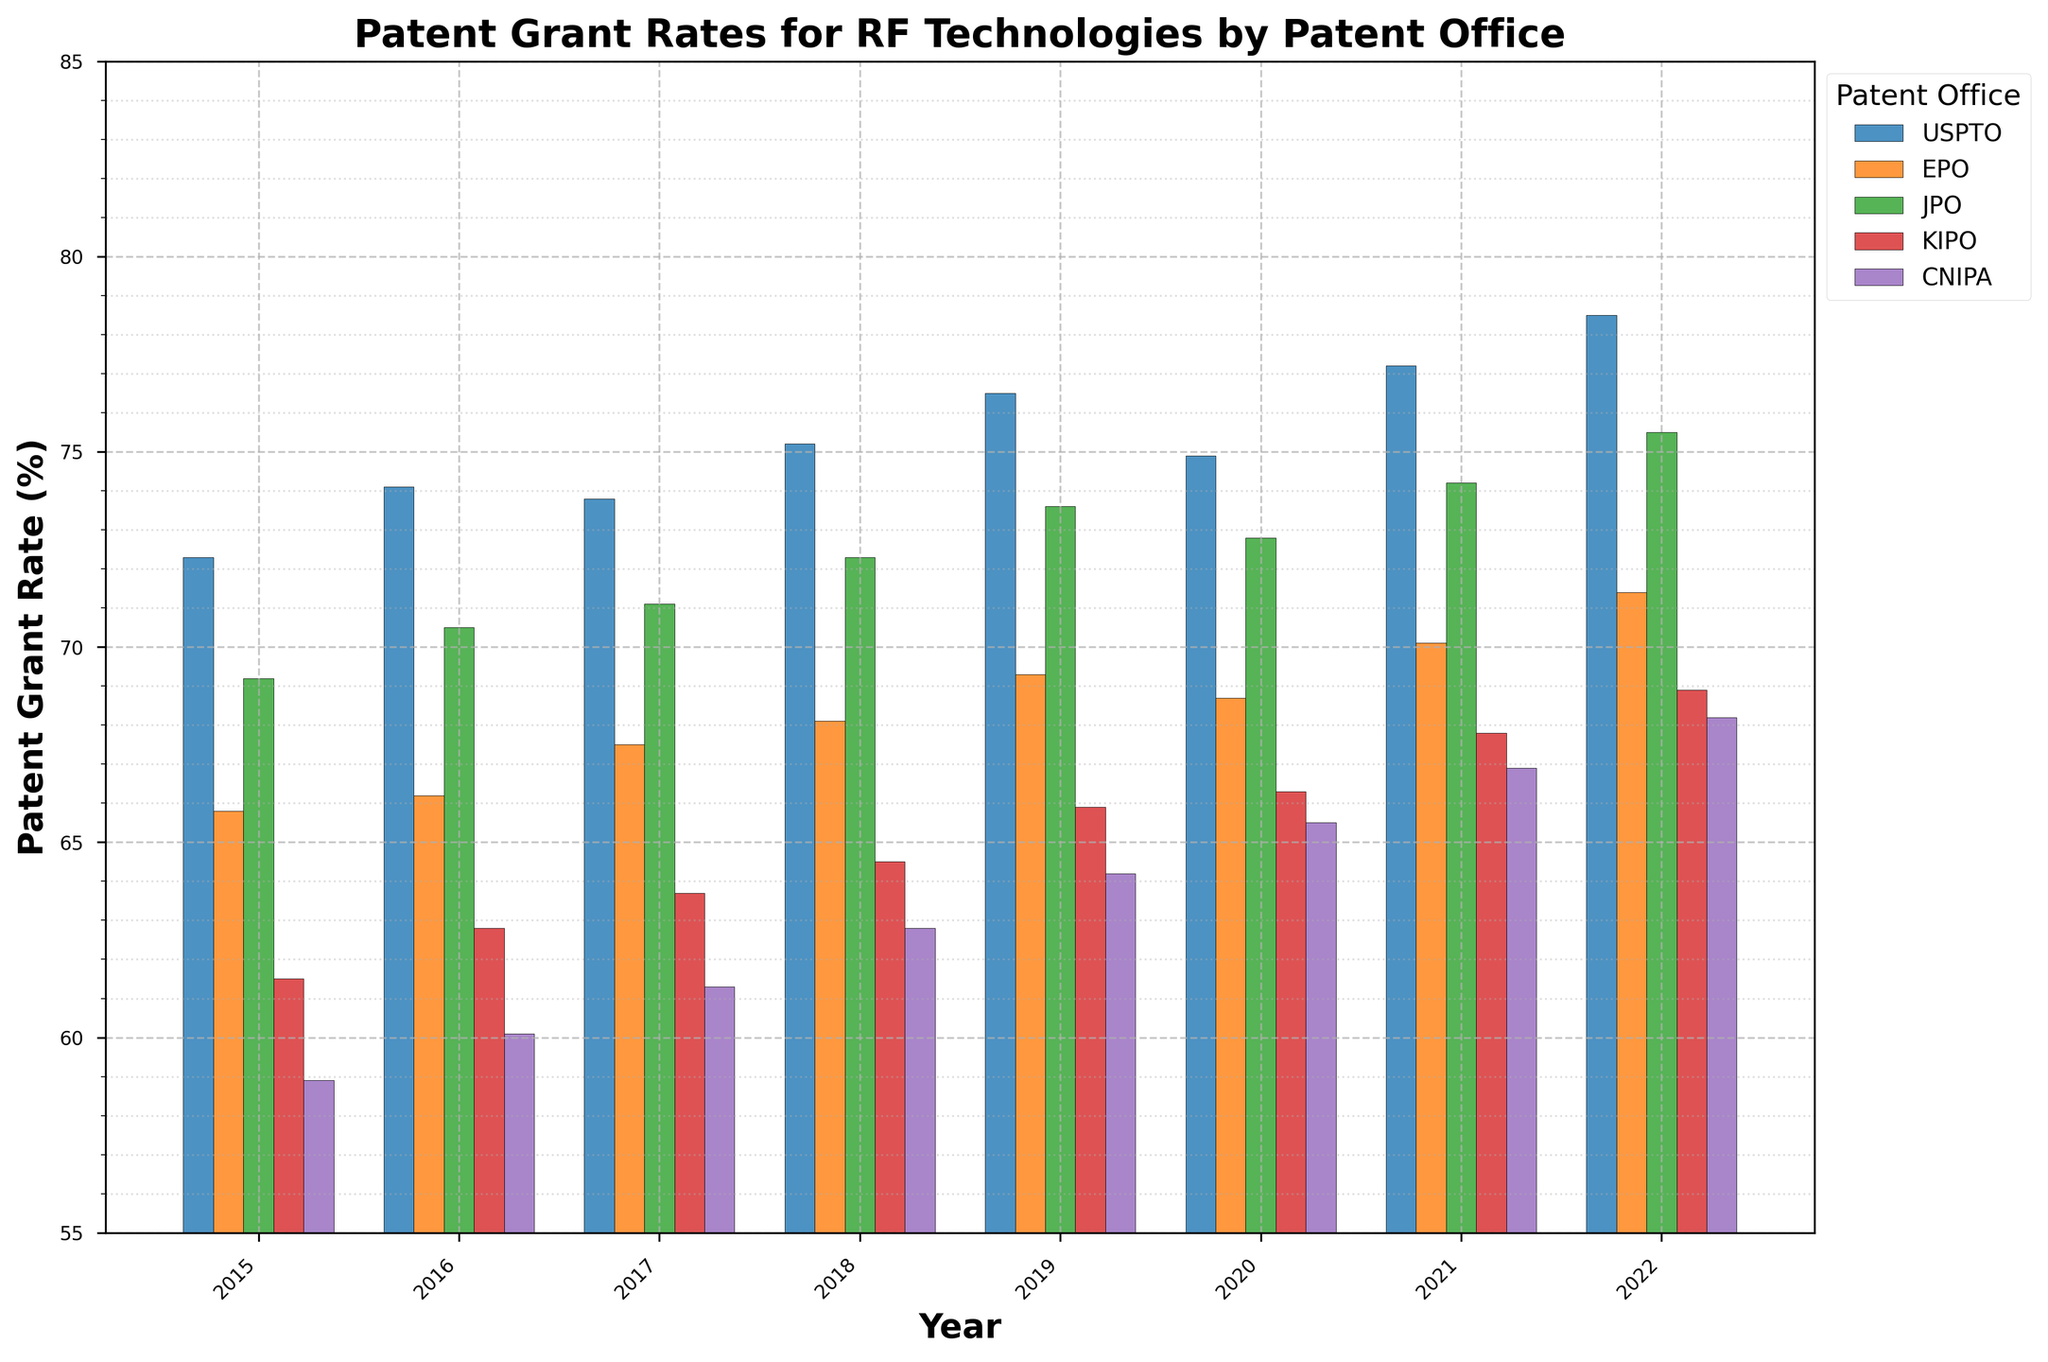What is the patent grant rate trend for USPTO from 2015 to 2022? To determine the trend, look at the heights of the bars corresponding to USPTO from 2015 to 2022. The heights increase from 72.3% in 2015 to 78.5% in 2022, indicating an overall increasing trend.
Answer: Increasing In which year did CNIPA have the lowest patent grant rate? Find the shortest bar among the bars for CNIPA, which indicates the lowest percentage. The shortest bar for CNIPA corresponds to the year 2015 with a rate of 58.9%.
Answer: 2015 How did the grant rates of EPO change from 2016 to 2020? Examine the bars for EPO from 2016 to 2020 and note their heights: 66.2%, 67.5%, 68.1%, 69.3%, and 68.7%. Notice there is a general increase with a minor dip in 2020.
Answer: Increased slightly Which patent office had the highest grant rate in 2021? Compare the heights of the bars for all offices in the year 2021. The highest bar corresponds to USPTO with a grant rate of 77.2%.
Answer: USPTO What is the difference in the grant rates between JPO and KIPO in 2022? Subtract the height of the KIPO bar from the height of the JPO bar for the year 2022. JPO's rate is 75.5% and KIPO's rate is 68.9%. The difference is 75.5% - 68.9% = 6.6%.
Answer: 6.6% Which office showed the most significant increase in grant rates from 2015 to 2022? Calculate the difference in grant rates from 2015 to 2022 for each office and compare them. USPTO increased from 72.3% to 78.5% (6.2%), EPO from 65.8% to 71.4% (5.6%), JPO from 69.2% to 75.5% (6.3%), KIPO from 61.5% to 68.9% (7.4%), and CNIPA from 58.9% to 68.2% (9.3%). The most significant increase is for CNIPA with 9.3%.
Answer: CNIPA How many patent offices had a higher grant rate than 70% in 2022? Check the heights of the bars for all offices in 2022 and count how many are above the 70% mark. USPTO (78.5%), EPO (71.4%), JPO (75.5%), and KIPO (68.9%) meet the criteria, totaling to 3.
Answer: 3 Is there any year where all five patent offices had a grant rate higher than 65%? Review the bars for each year and see if all five offices have bars higher than 65%. In 2021 and 2022, all offices have grant rates higher than 65%. 2020 has KIPO (66.3%) and CNIPA (65.5%) higher than 65%, as does 2019, but not earlier years.
Answer: Yes, multiple years 